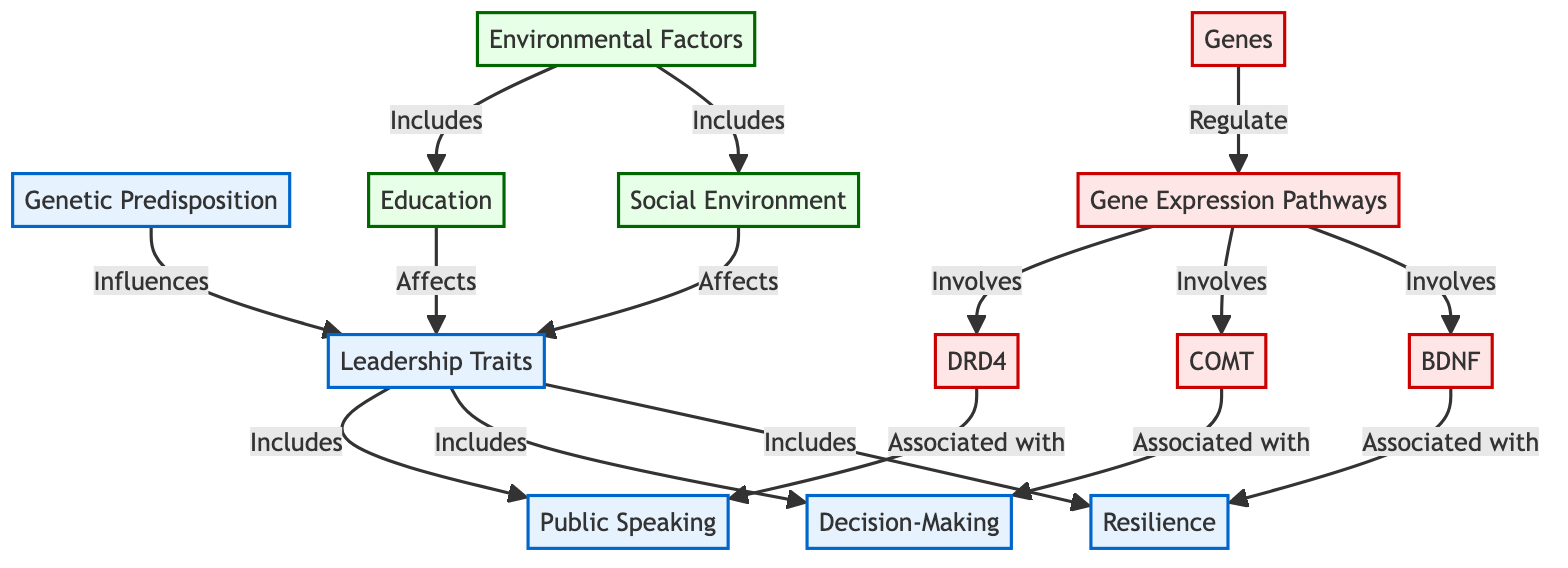What are the three leadership traits listed in the diagram? The diagram specifies that the leadership traits include resilience, decision-making, and public speaking. This information can be found directly under the "Leadership Traits" node, where the specific traits are clearly indicated.
Answer: resilience, decision-making, public speaking Which gene is associated with decision-making? According to the diagram, the gene associated with decision-making is COMT. This is shown by looking at the connection from the gene expression pathways node to the decision-making trait, which specifically names the COMT gene.
Answer: COMT How many environmental factors are mentioned in the diagram? The diagram lists two environmental factors: social environment and education. By counting the connections from the environmental factors node, we can identify these two that influence leadership traits.
Answer: 2 What do BDNF, COMT and DRD4 have in common? BDNF, COMT, and DRD4 are all genes that are involved in gene expression pathways according to the diagram. They are grouped together under the gene expression pathways node, indicating that they play a role in the genetic predisposition to leadership traits.
Answer: genes How do environmental factors affect leadership traits? The diagram illustrates that environmental factors, which include social environment and education, directly affect leadership traits. This relationship is demonstrated through the connections shown in the lower part of the diagram, where the environmental factors lead to the leadership traits node.
Answer: affects Which leadership trait is associated with BDNF? The leadership trait associated with BDNF is resilience. This connection is clearly shown in the diagram where the BDNF gene points to the resilience trait under the leadership traits node.
Answer: resilience What role do genes play in relation to gene expression pathways? Genes regulate gene expression pathways according to the diagram. This relationship is depicted by the arrow from the genes node pointing towards the gene expression pathways node, indicating a regulatory influence.
Answer: regulate Which environmental factor affects public speaking skills? The education factor affects public speaking skills as indicated by the connection from the education node to the leadership traits node, which includes public speaking. This relationship shows that education contributes to the development of this trait.
Answer: education What influences leadership traits according to the diagram? Leadership traits are influenced by both genetic predisposition and environmental factors as indicated in the diagram. The arrows from the genetic predisposition and environmental factors point towards the leadership traits node, combining both aspects.
Answer: genetic predisposition and environmental factors 